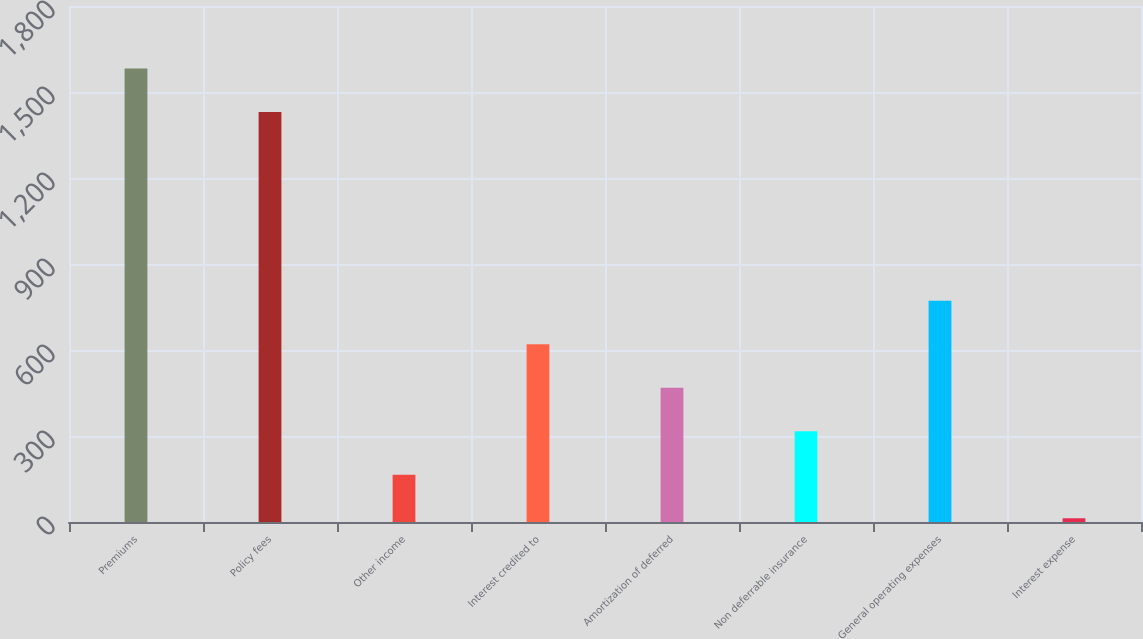<chart> <loc_0><loc_0><loc_500><loc_500><bar_chart><fcel>Premiums<fcel>Policy fees<fcel>Other income<fcel>Interest credited to<fcel>Amortization of deferred<fcel>Non deferrable insurance<fcel>General operating expenses<fcel>Interest expense<nl><fcel>1581.7<fcel>1430<fcel>164.7<fcel>619.8<fcel>468.1<fcel>316.4<fcel>771.5<fcel>13<nl></chart> 